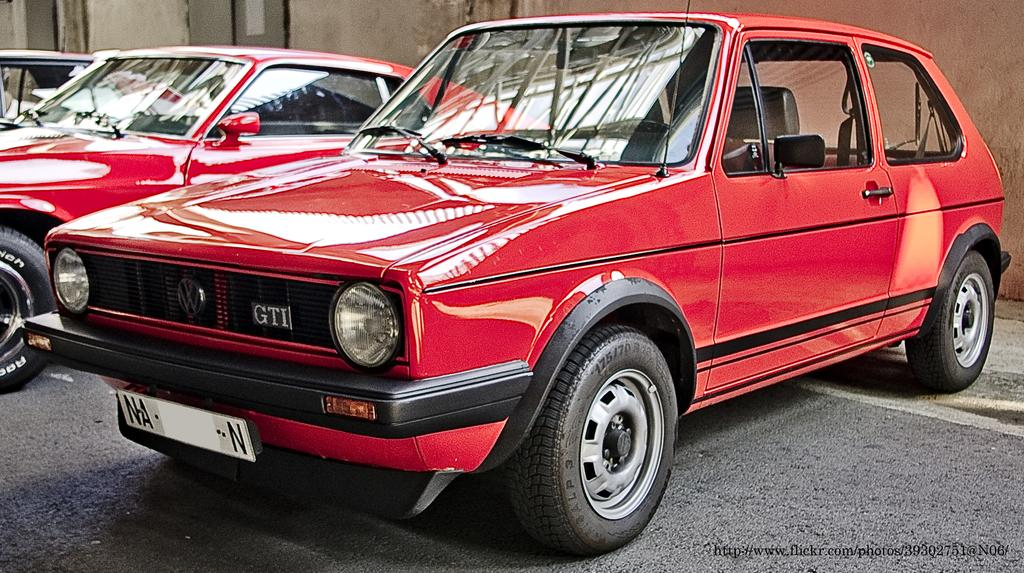<image>
Offer a succinct explanation of the picture presented. A red Volkswagen with the letters GTI in its grill. 